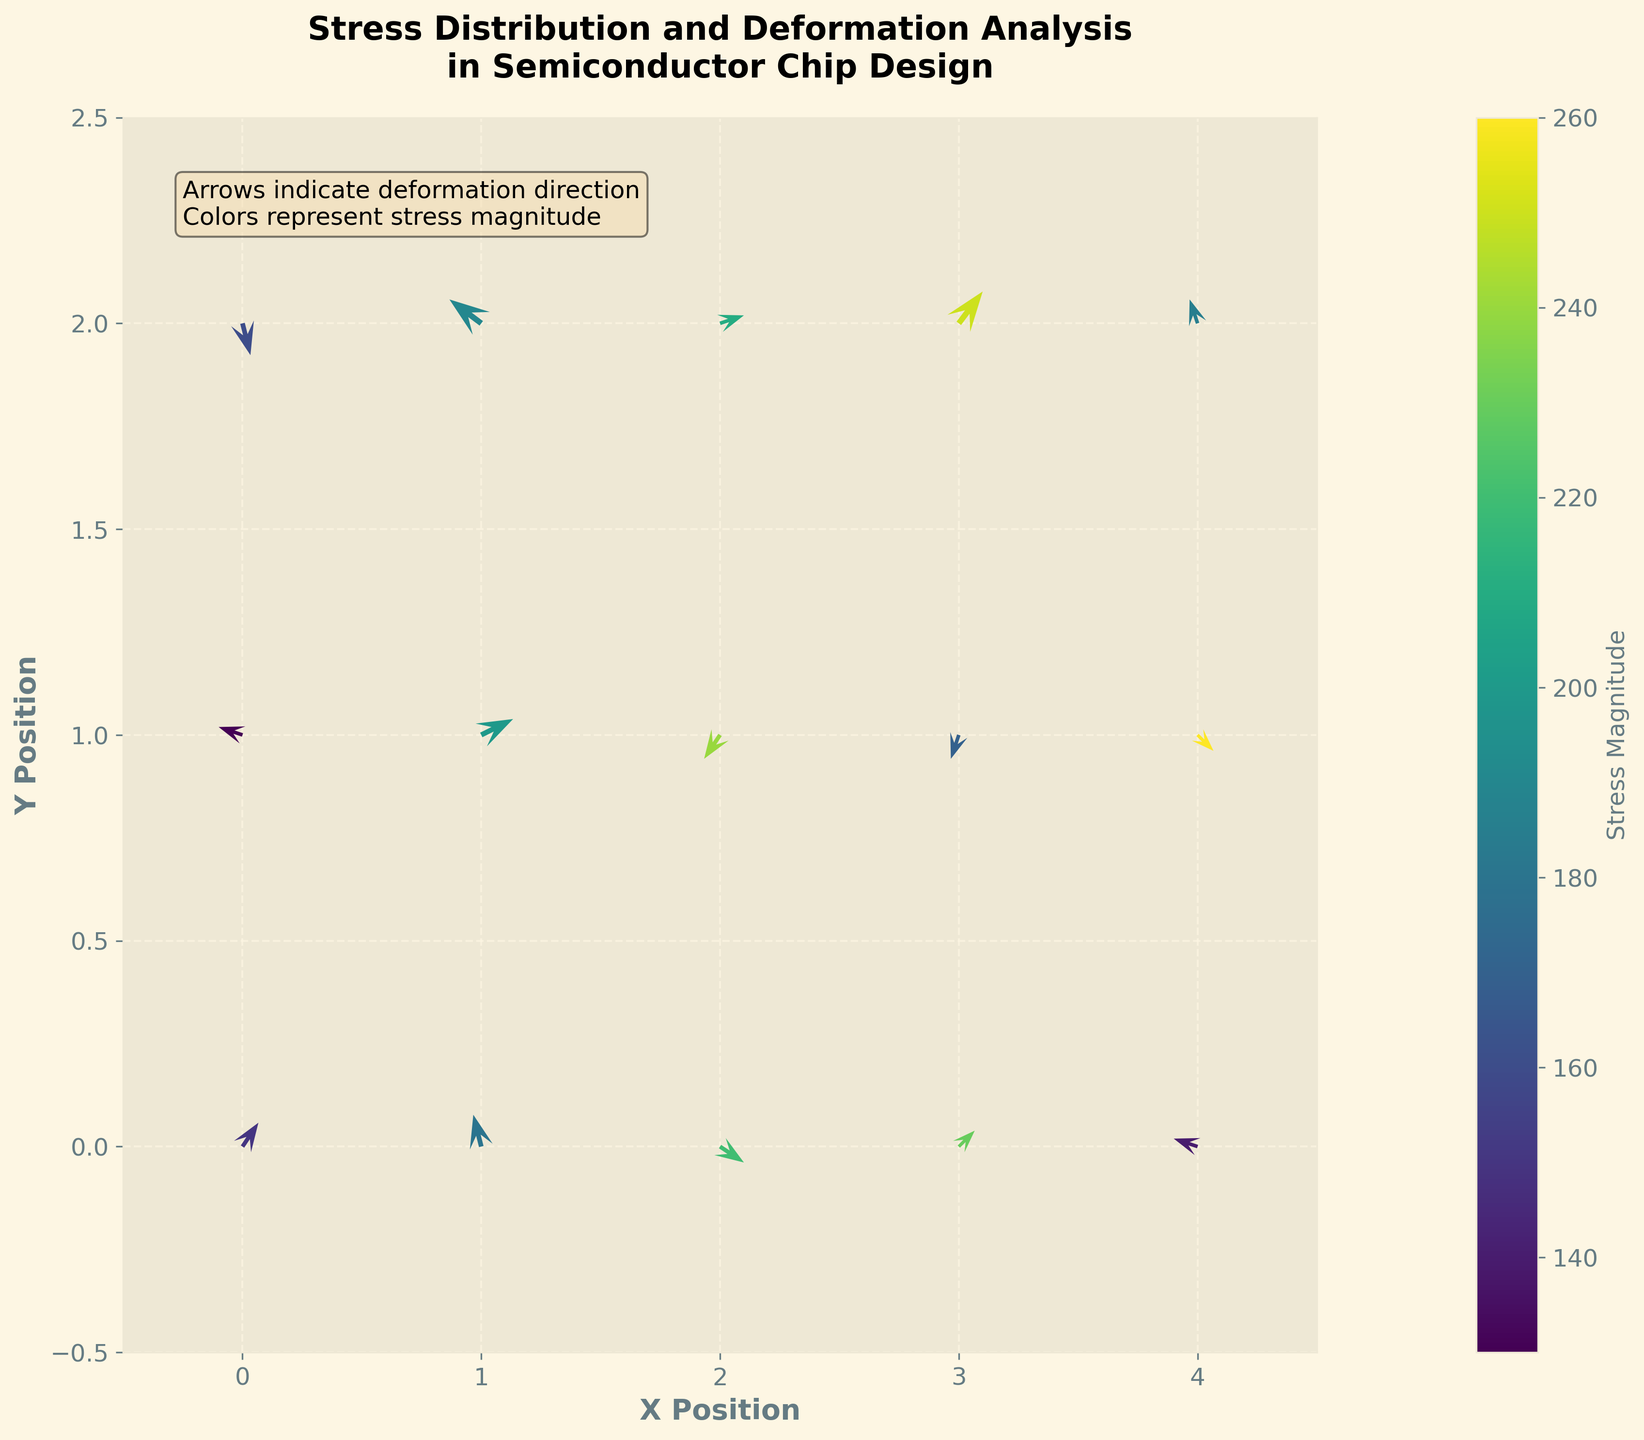What does the title of the figure indicate? The title of the figure is displayed at the top and it describes the content that the plot represents. It reads "Stress Distribution and Deformation Analysis in Semiconductor Chip Design". This indicates that the plot is visualizing how stress is distributed and how the material deforms in a semiconductor chip.
Answer: Stress Distribution and Deformation Analysis in Semiconductor Chip Design What do the arrows in the quiver plot represent? The arrows in a quiver plot usually represent vectors, indicating direction and magnitude. In the context of this figure, the arrows are showing the direction and magnitude of deformation in the semiconductor chip. The direction and length of each arrow denote how and how much the material deforms at each point.
Answer: Direction and magnitude of deformation What does the color indicate in this quiver plot? The color in the quiver plot represents the stress magnitude, as indicated by the color bar on the side. Different colors correlate with varying levels of stress, with the color mapping to the stress magnitude via a 'viridis' color scheme.
Answer: Stress magnitude What is the color of the maximum stress value, and where is it located? To find the maximum stress value, we refer to the color bar which shows the stress magnitude range and the point with the corresponding color on the plot. The maximum stress value is 260, associated with the upper range of the color bar. This color is found at the point (4, 1).
Answer: The maximum stress value is 260, located at (4, 1) How many arrows originate from the (1, 1) position, and what is the direction of the deformation there? There is one arrow originating from each data point. At the (1, 1) position, the arrow is pointing slightly upwards to the right, indicating a deformation direction with components (0.4, 0.2).
Answer: One arrow, direction is (0.4, 0.2) Which point has the largest deformation vector, and what is its corresponding stress magnitude? To determine the point with the largest deformation vector, we observe the length of the arrows. The point with the largest arrow appears at (3, 2) with deformation components (0.3, 0.4). The stress magnitude at this point, as indicated by the color bar, is 250.
Answer: (3, 2), stress magnitude is 250 Compare the deformation vectors at (2, 0) and (4, 0). Which one has a greater magnitude? To compare the deformation vectors, calculate their magnitudes using the formula sqrt(u^2 + v^2). For (2, 0), the vector is (0.3, -0.2) and its magnitude is sqrt(0.3^2 + (-0.2)^2) ≈ 0.36. For (4, 0), the vector is (-0.3, 0.1) and its magnitude is sqrt((-0.3)^2 + 0.1^2) ≈ 0.32.
Answer: (2, 0) has a greater magnitude What additional information does the text box on the plot provide? The text box on the plot provides supplementary information about the elements being visualized. It states, "Arrows indicate deformation direction. Colors represent stress magnitude," clarifying the meaning of the arrows and the coloring used in the plot.
Answer: Arrows indicate deformation direction, Colors represent stress magnitude How does the deformation at (1, 2) compare to that at (1, 0) in both direction and magnitude of the deformation vectors? At (1, 2), the deformation vector is (-0.4, 0.3) and at (1, 0), it is (-0.1, 0.4). The vector magnitudes are sqrt((-0.4)^2 + 0.3^2) ≈ 0.5 and sqrt((-0.1)^2 + 0.4^2) ≈ 0.41, respectively. Directionally, the two vectors differ, with (1, 2) having a larger negative x-component and (1, 0) having a larger positive y-component.
Answer: (1, 2) has a greater magnitude and different direction What is indicated by the grid lines in the plot, and why might they be useful? The grid lines in the plot provide a reference to accurately determine the position of the arrows and their relative distances. They help in visually aligning the deformations with specific coordinates and in comparing vectors across the grid systematically.
Answer: Reference for position alignment and comparison 